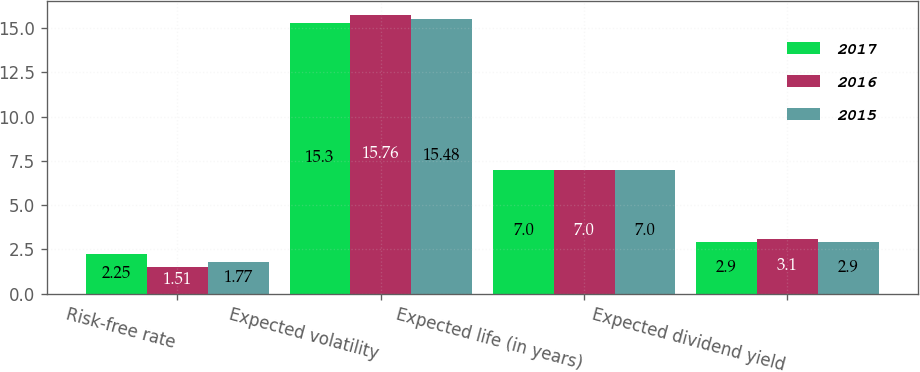Convert chart to OTSL. <chart><loc_0><loc_0><loc_500><loc_500><stacked_bar_chart><ecel><fcel>Risk-free rate<fcel>Expected volatility<fcel>Expected life (in years)<fcel>Expected dividend yield<nl><fcel>2017<fcel>2.25<fcel>15.3<fcel>7<fcel>2.9<nl><fcel>2016<fcel>1.51<fcel>15.76<fcel>7<fcel>3.1<nl><fcel>2015<fcel>1.77<fcel>15.48<fcel>7<fcel>2.9<nl></chart> 